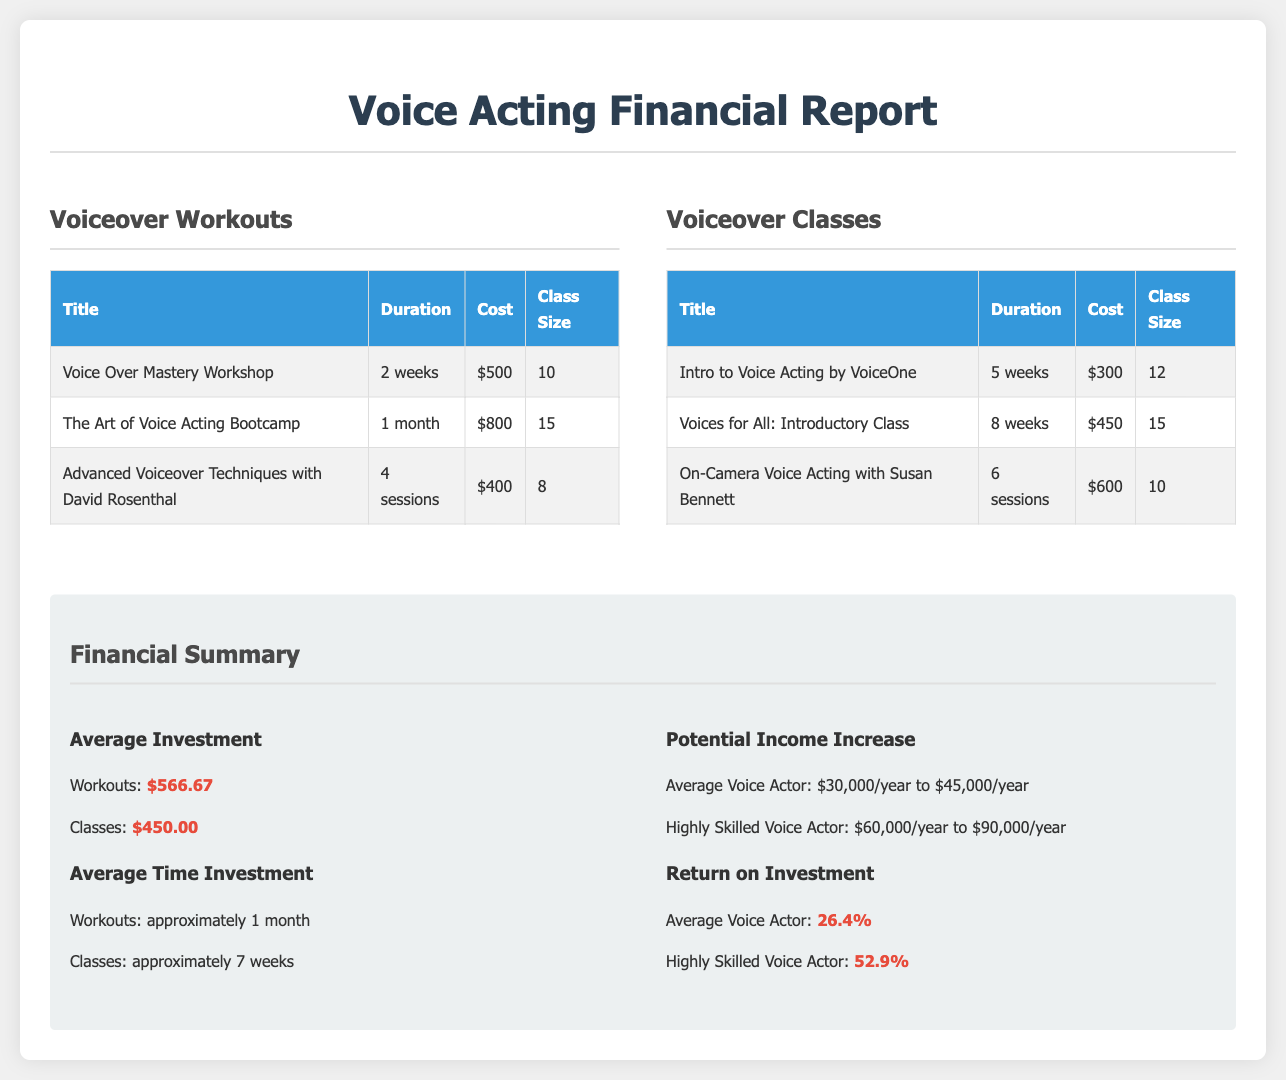What is the cost of the Voice Over Mastery Workshop? The cost of the Voice Over Mastery Workshop is listed in the table under Voiceover Workouts.
Answer: $500 What is the duration of The Art of Voice Acting Bootcamp? The duration of The Art of Voice Acting Bootcamp can be found in the Voiceover Workouts section.
Answer: 1 month How many sessions does the On-Camera Voice Acting class have? The number of sessions for the On-Camera Voice Acting class is outlined in the Voiceover Classes table.
Answer: 6 sessions What is the average investment for Voiceover Classes? The average investment for Voiceover Classes is mentioned in the Financial Summary section of the report.
Answer: $450.00 What is the potential income range for a Highly Skilled Voice Actor? The potential income range for a Highly Skilled Voice Actor is detailed in the Potential Income Increase section.
Answer: $60,000/year to $90,000/year What is the average time investment for workouts? The average time investment for workouts is provided in the Financial Summary of the document.
Answer: approximately 1 month What is the return on investment for the average voice actor? The return on investment for the average voice actor is specified in the Return on Investment section of the Financial Summary.
Answer: 26.4% How many classes are listed in the Voiceover Classes section? The number of classes in the Voiceover Classes section can be inferred by counting the entries in the table.
Answer: 3 What is the class size for the Advanced Voiceover Techniques? The class size for the Advanced Voiceover Techniques can be found in the table for Voiceover Workouts.
Answer: 8 